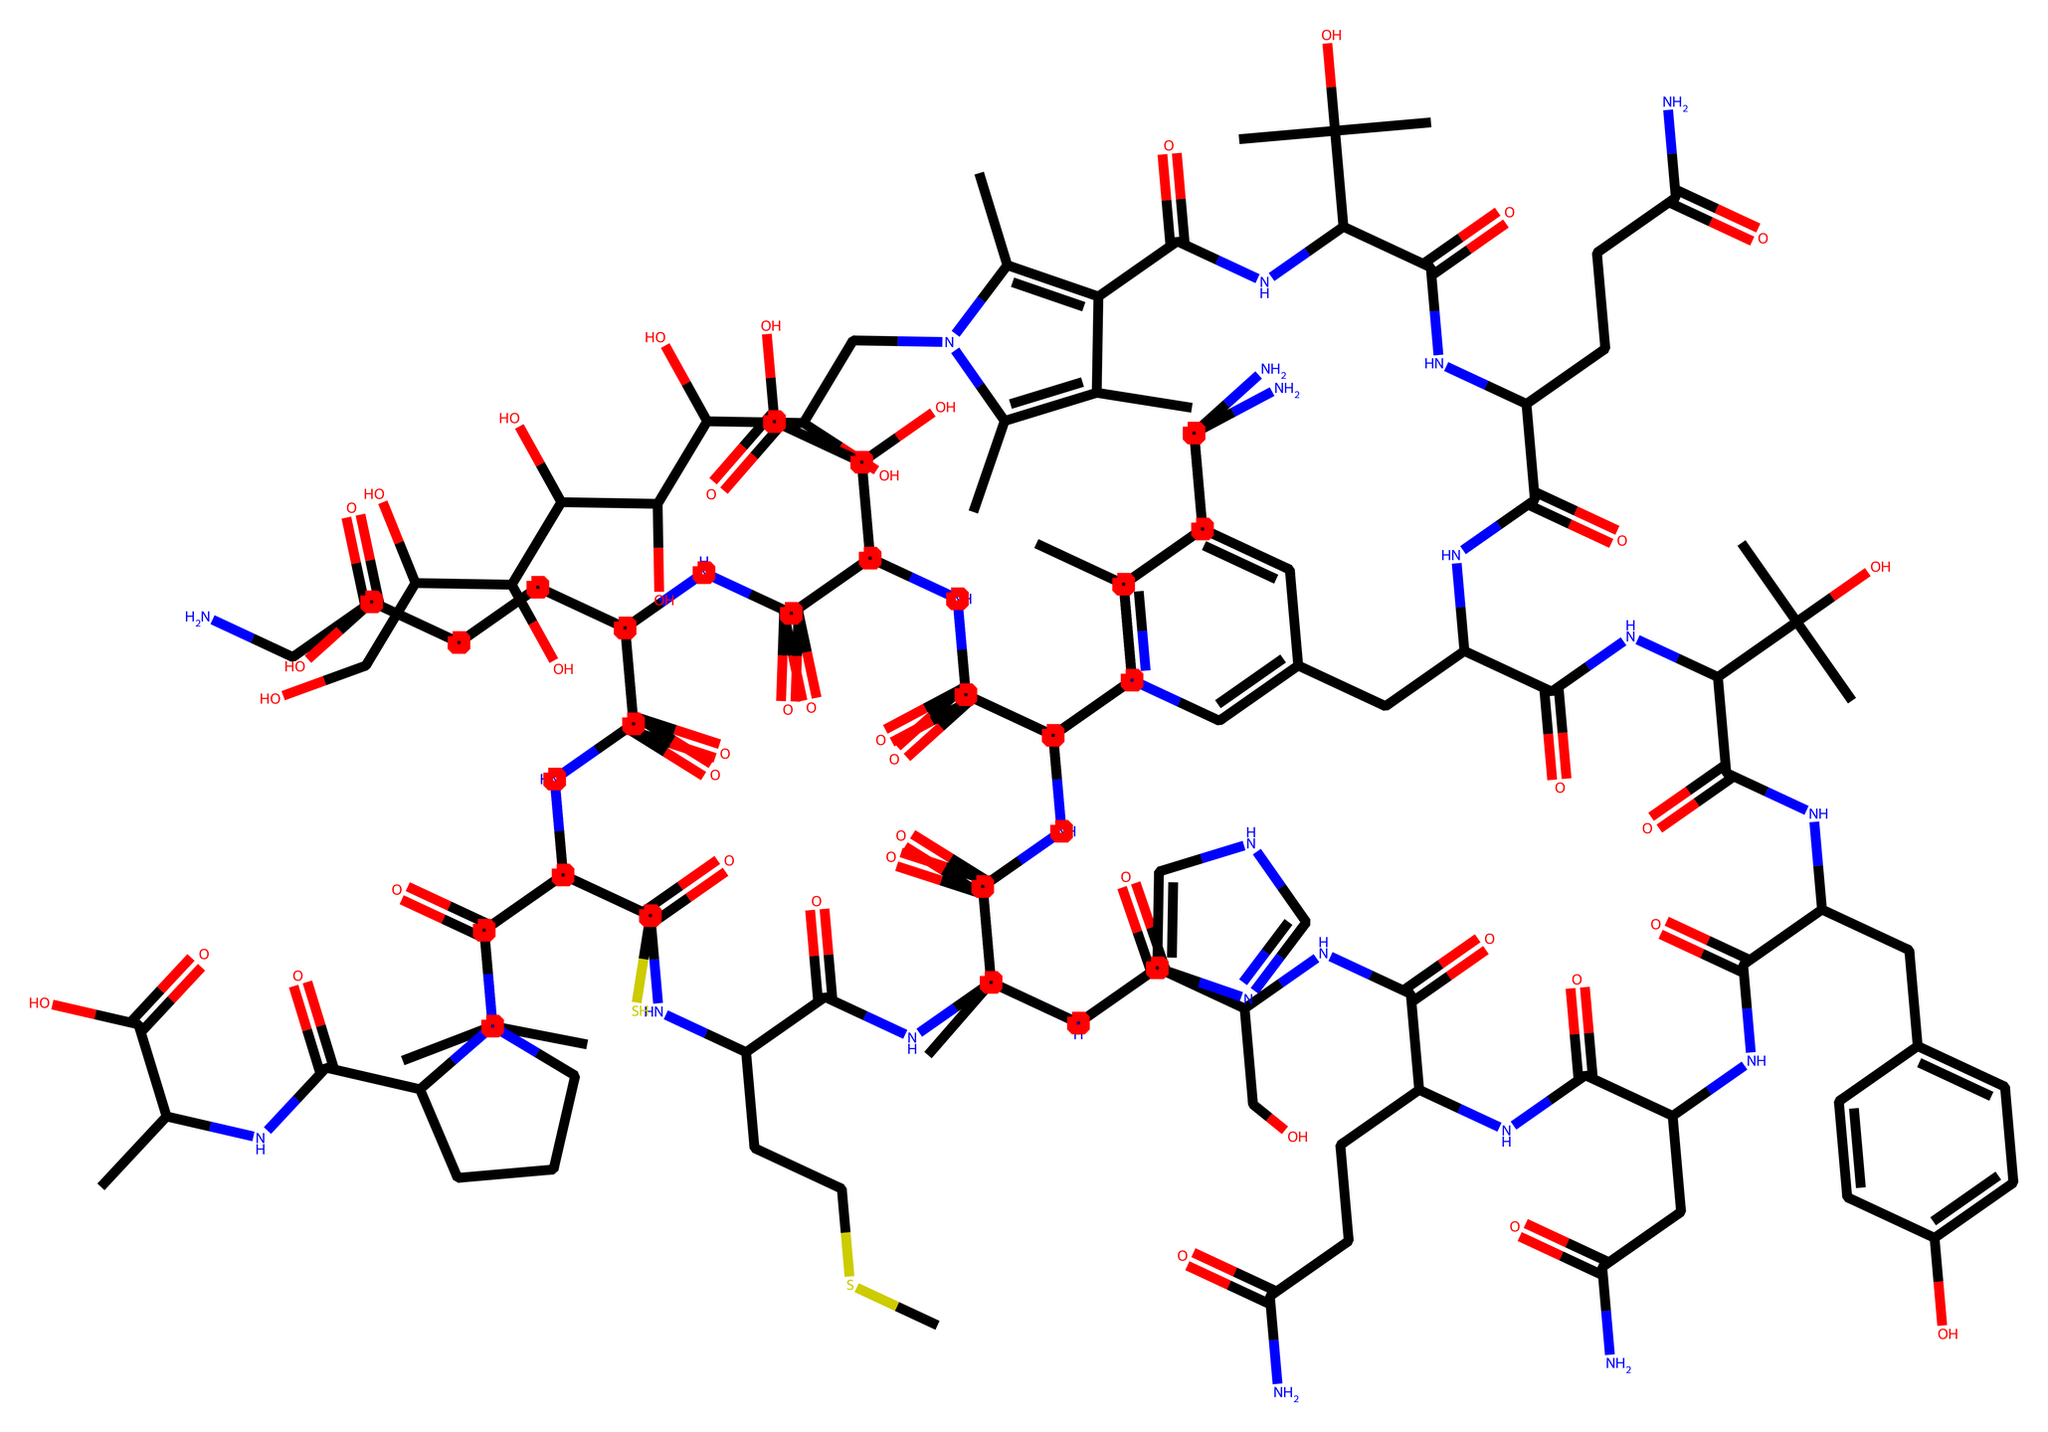What is the molecular formula of this compound? To determine the molecular formula, we can analyze the chemical structure represented by the SMILES string. Count the number of each type of atom present in the chemical, which typically includes carbon (C), hydrogen (H), nitrogen (N), and oxygen (O). In this case, the count results in a molecular formula of C63H88N14O17.
Answer: C63H88N14O17 How many nitrogen atoms are present? By examining the SMILES notation, we can identify and count the nitrogen (N) symbols. In this case, there are 14 nitrogen atoms present in the structure.
Answer: 14 What characteristic functionality is suggested by the presence of multiple hydroxyl (OH) groups? The presence of multiple hydroxyl (OH) groups indicates that this compound is likely to be a polyol or sugar alcohol. Hydroxyl groups increase water solubility and influence biological activity.
Answer: polyol How many distinct carbon skeletons can be found in vitamin B12 based on the chemical structure? By analyzing the structure in the SMILES representation, we recognize it is a complex molecule consisting of multiple interconnected rings and chains. After careful examination, we find that there are several components indicative of different carbon skeletons. After breaking down the structure, we can classify it into 4 distinct carbon skeletons.
Answer: 4 What role does vitamin B12 play in nerve function according to its chemical structure? The presence of cobalt in the center of the corrin structure of vitamin B12 indicates its role as a cofactor in enzymatic reactions in nerve function, particularly in myelin formation. This cobalt coordination is critical for metabolism and maintaining nerve health.
Answer: cofactor How does the arrangement of atoms affect the biological activity of vitamin B12? The specific arrangement of atoms and the presence of functional groups, like amides and hydroxyls, contribute to the chemical interactions with enzymes and receptor sites in the body. This structure allows vitamin B12 to participate effectively in biological processes, influencing its overall activity in nerve function and DNA synthesis.
Answer: enhances biological activity 